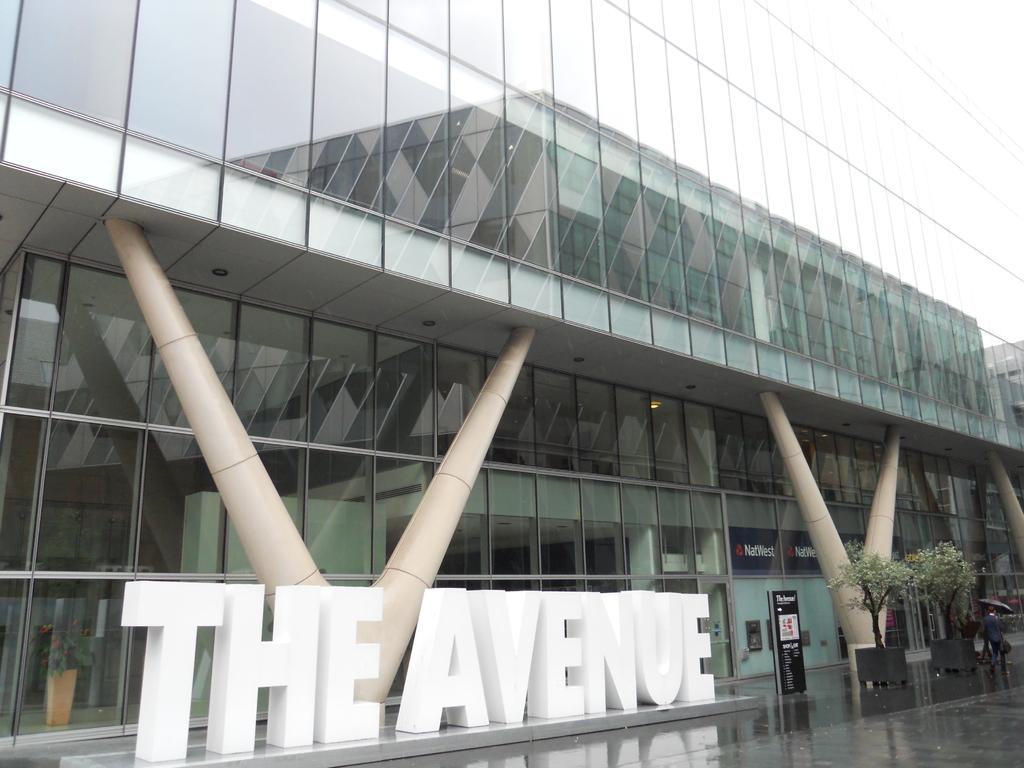What type of building is shown in the image? The image shows the outside view of a glass building. Can you read the name of the building in the image? Yes, the name of the building is at the bottom of the image. What can be seen in the background of the image? There are trees visible in the image. What is the person in the image doing? The person is walking on a path with an umbrella. How many people are in the crowd gathered around the building in the image? There is no crowd present in the image; it only shows a person walking on a path with an umbrella. What type of sound can be heard coming from the thunder in the image? There is no thunder present in the image; it only shows a person walking on a path with an umbrella. 